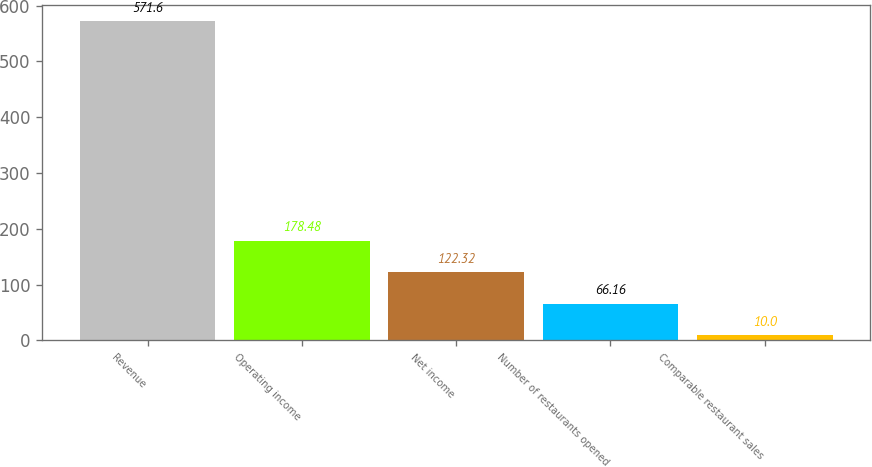Convert chart. <chart><loc_0><loc_0><loc_500><loc_500><bar_chart><fcel>Revenue<fcel>Operating income<fcel>Net income<fcel>Number of restaurants opened<fcel>Comparable restaurant sales<nl><fcel>571.6<fcel>178.48<fcel>122.32<fcel>66.16<fcel>10<nl></chart> 